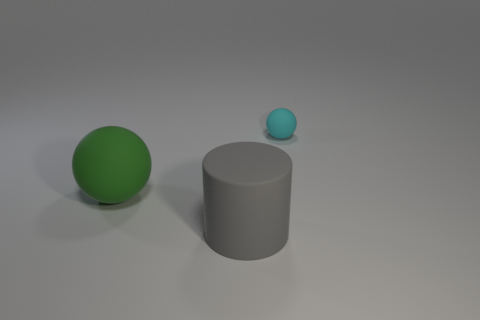Add 3 yellow things. How many objects exist? 6 Subtract all cylinders. How many objects are left? 2 Subtract 1 cylinders. How many cylinders are left? 0 Subtract all cyan balls. Subtract all small yellow shiny spheres. How many objects are left? 2 Add 1 green matte spheres. How many green matte spheres are left? 2 Add 1 small cyan metal cylinders. How many small cyan metal cylinders exist? 1 Subtract 0 brown cylinders. How many objects are left? 3 Subtract all cyan cylinders. Subtract all yellow cubes. How many cylinders are left? 1 